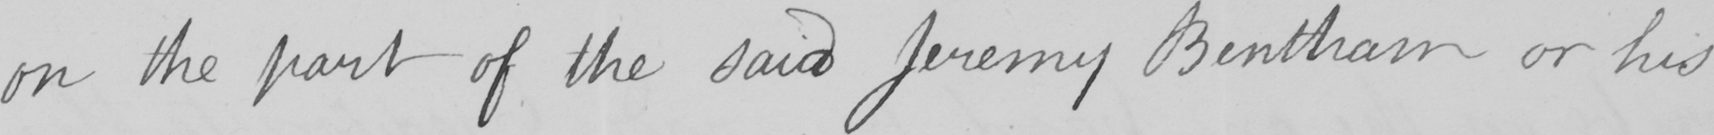Please transcribe the handwritten text in this image. on the part of the said Jeremy Bentham or his 